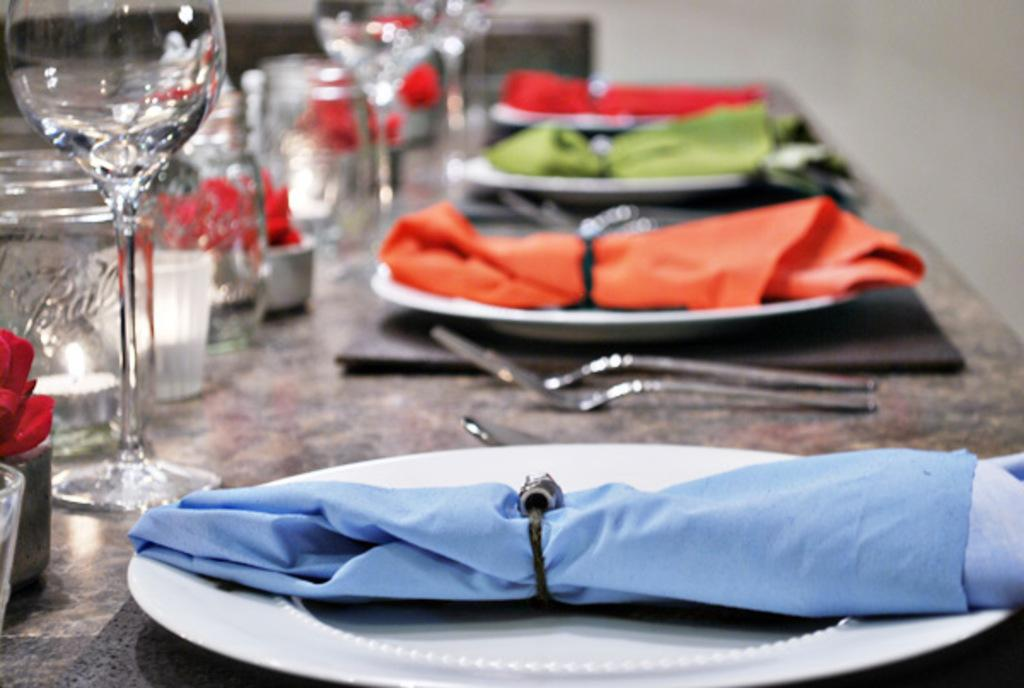What type of tableware can be seen in the image? There are glasses, a fork, and a spoon in the image. What items might be used for cleaning or wiping in the image? Napkins are in the plates in the image for cleaning or wiping. What is the purpose of the candle in the image? The candle in a jar in the image might be used for lighting or decoration. What is present on the table in the image? Dining placemats, glasses, a fork, a spoon, napkins in plates, a candle in a jar, and other objects are present on the table in the image. How is the background of the image depicted? The background of the image is blurred. What type of collar is visible on the side of the unit in the image? There is no collar or unit present in the image; it features dining tableware and other objects on a table. 